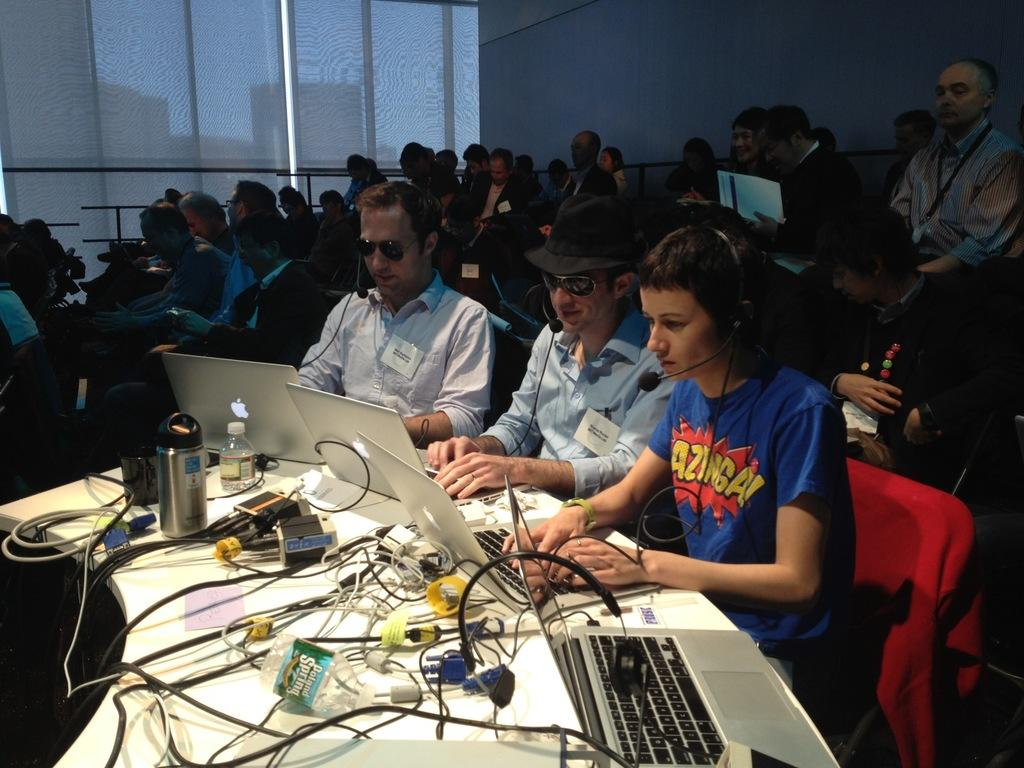How many people are in the image? There is a group of people in the image. What are the people doing in the image? The people are sitting on chairs. What is the background of the image? There is a glass wall in the image. Where are the chairs located in relation to the glass wall? The chairs are beside the glass wall. What is on the table in front of the chairs? There is a table in front of the chairs, and a laptop is present on the table. How is the laptop connected in the image? The laptop is connected with cables. What other objects can be seen on the table? There are other objects on the table. What type of bead is being used to decorate the street in the image? There is no street or bead present in the image. How does the coastline look in the image? There is no coastline present in the image. 